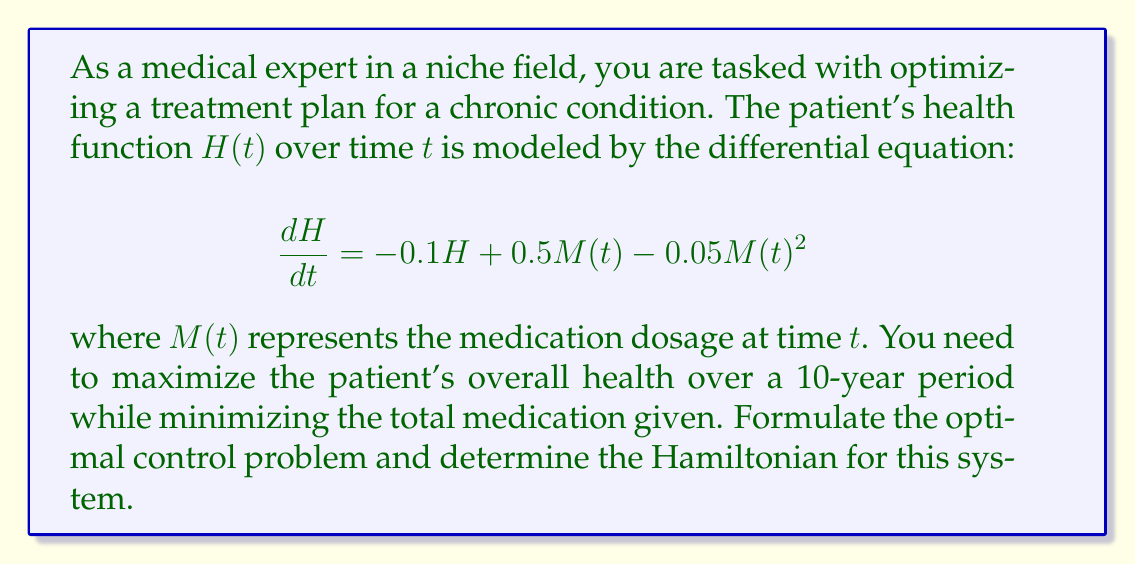Solve this math problem. To optimize the treatment plan using calculus of variations and dynamic programming, we'll follow these steps:

1) First, we need to define our objective function. We want to maximize health while minimizing medication. Let's use a weighted sum:

   $$J = \int_0^{10} [H(t) - \alpha M(t)] dt$$

   where $\alpha$ is a weighting factor balancing health benefit and medication cost.

2) The state equation is given by:

   $$\frac{dH}{dt} = -0.1H + 0.5M(t) - 0.05M(t)^2$$

3) To formulate the optimal control problem, we use Pontryagin's Maximum Principle. We introduce a costate variable $\lambda(t)$.

4) The Hamiltonian for this system is:

   $$\mathcal{H} = H - \alpha M + \lambda(-0.1H + 0.5M - 0.05M^2)$$

5) This Hamiltonian encapsulates the instantaneous objective (health minus weighted medication) plus the product of the costate and the rate of change of the state variable.

6) The optimal control will be found by maximizing this Hamiltonian with respect to the control variable $M(t)$.

7) The costate equation is:

   $$\frac{d\lambda}{dt} = -\frac{\partial \mathcal{H}}{\partial H} = -1 + 0.1\lambda$$

8) The optimality condition is:

   $$\frac{\partial \mathcal{H}}{\partial M} = -\alpha + \lambda(0.5 - 0.1M) = 0$$

These equations, along with the state equation and appropriate boundary conditions, form a two-point boundary value problem that can be solved to find the optimal treatment plan.
Answer: $\mathcal{H} = H - \alpha M + \lambda(-0.1H + 0.5M - 0.05M^2)$ 